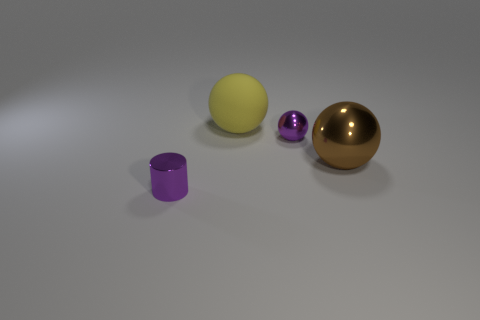Subtract all metallic spheres. How many spheres are left? 1 Add 4 large yellow matte balls. How many objects exist? 8 Subtract all brown balls. How many balls are left? 2 Subtract all cylinders. How many objects are left? 3 Subtract 1 cylinders. How many cylinders are left? 0 Subtract all cyan cylinders. How many yellow spheres are left? 1 Subtract all tiny shiny objects. Subtract all matte objects. How many objects are left? 1 Add 2 big yellow things. How many big yellow things are left? 3 Add 1 brown balls. How many brown balls exist? 2 Subtract 0 cyan blocks. How many objects are left? 4 